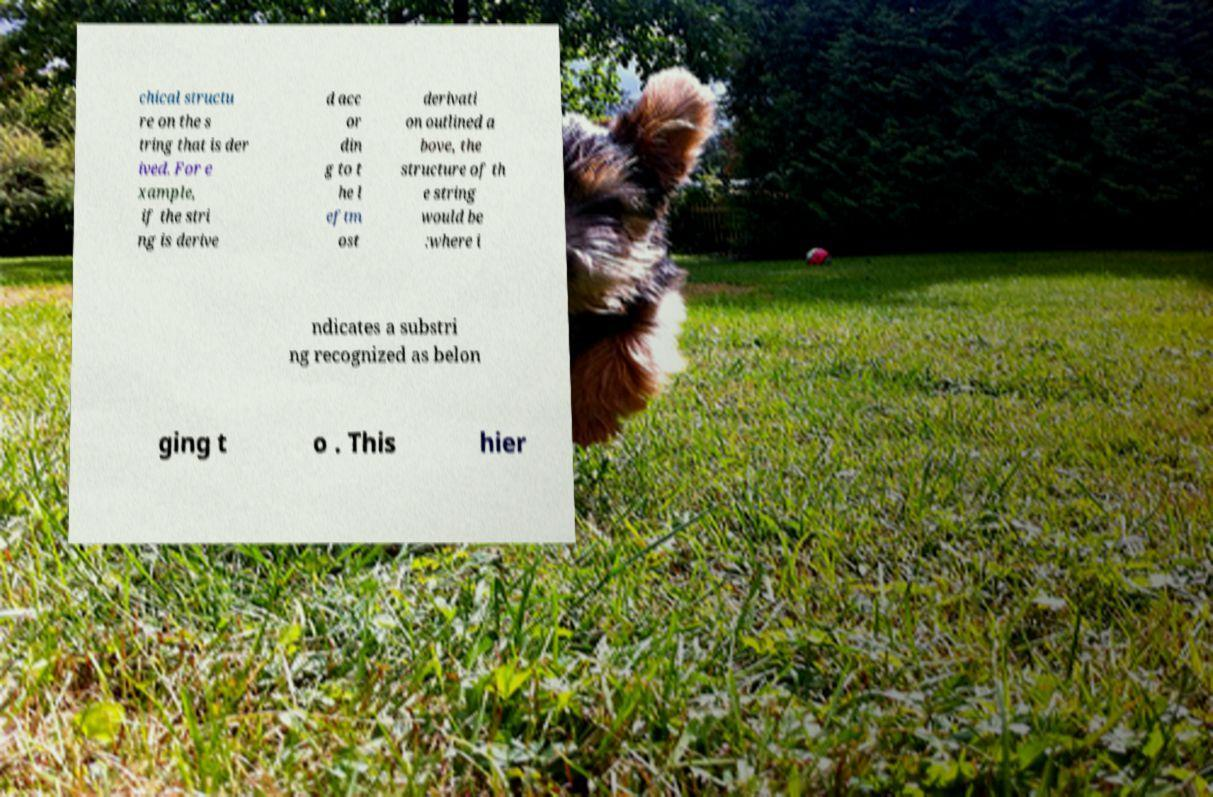Could you assist in decoding the text presented in this image and type it out clearly? chical structu re on the s tring that is der ived. For e xample, if the stri ng is derive d acc or din g to t he l eftm ost derivati on outlined a bove, the structure of th e string would be :where i ndicates a substri ng recognized as belon ging t o . This hier 